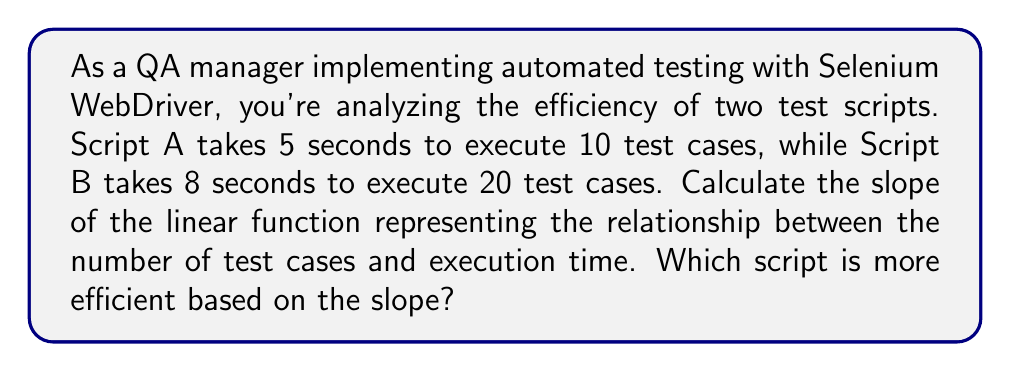Teach me how to tackle this problem. To determine the efficiency of the test scripts, we'll calculate the slope of the linear function for each script. The slope represents the rate of change in execution time per test case.

1. For Script A:
   - Number of test cases: $x_1 = 10$
   - Execution time: $y_1 = 5$ seconds
   
2. For Script B:
   - Number of test cases: $x_2 = 20$
   - Execution time: $y_2 = 8$ seconds

3. Calculate the slope using the point-slope formula:
   $$ m = \frac{y_2 - y_1}{x_2 - x_1} $$

4. Substitute the values:
   $$ m = \frac{8 - 5}{20 - 10} = \frac{3}{10} = 0.3 $$

5. Interpret the result:
   The slope of 0.3 seconds per test case means that, on average, each additional test case increases the execution time by 0.3 seconds.

6. Compare with Script A:
   For Script A, we can calculate its slope:
   $$ m_A = \frac{5}{10} = 0.5 $$

   Script A has a higher slope, meaning it takes more time per test case.

Therefore, Script B (with a slope of 0.3) is more efficient than Script A (with a slope of 0.5), as it requires less additional time for each new test case.
Answer: 0.3 seconds/test case; Script B 